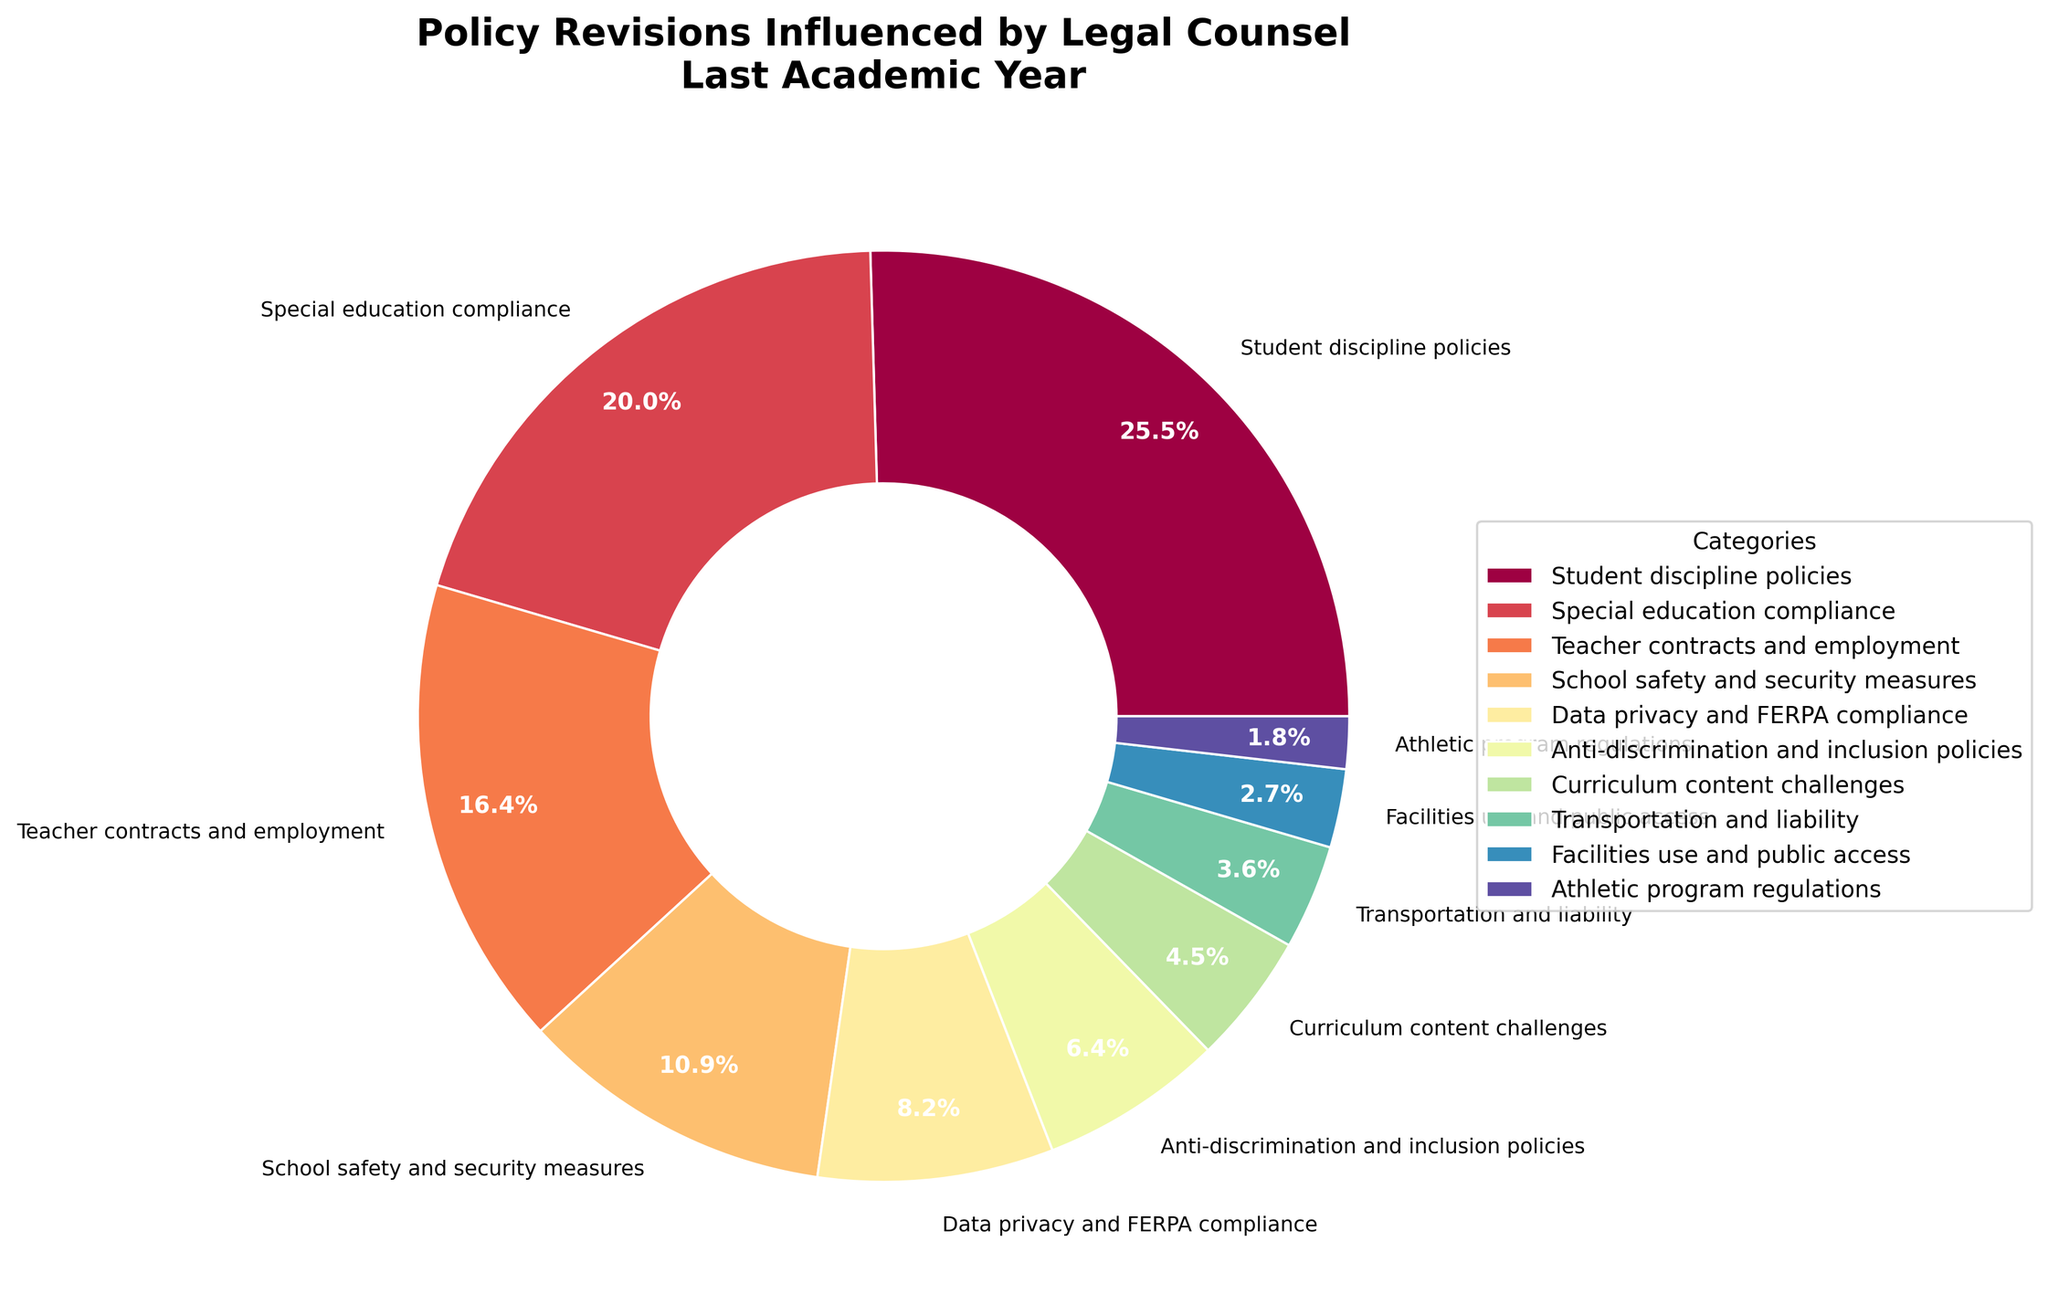Which category accounts for the highest percentage of policy revisions influenced by legal counsel? Student discipline policies account for the highest percentage at 28%. This can be directly observed from the figure where the 'Student discipline policies' segment is the largest.
Answer: Student discipline policies (28%) How much larger is the percentage for 'Student discipline policies' compared to 'School safety and security measures'? To find the difference, subtract the smaller percentage from the larger one. That is 28% (Student discipline policies) - 12% (School safety and security measures) = 16%.
Answer: 16% What's the combined percentage of policy revisions influenced by legal counsel for 'Teacher contracts and employment' and 'Special education compliance'? Sum the percentages for 'Teacher contracts and employment' (18%) and 'Special education compliance' (22%). So, 18% + 22% = 40%.
Answer: 40% Which categories are indicated by shades of red in the pie chart? Without specifying exact color codes, we look at the visual hues on the chart. By observing, the categories 'Student discipline policies' and 'Anti-discrimination and inclusion policies' are represented by shades of red.
Answer: Student discipline policies and Anti-discrimination and inclusion policies Are there any categories influenced equally by legal counsel? No, all categories have unique percentages, indicating that none are equally influenced. This is observed by visually checking that each segment has a different size and percentage label.
Answer: No What percentage of policy revisions are influenced by legal counsel in categories related to student issues (Student discipline policies and Special education compliance)? Sum the percentages of the 'Student discipline policies' (28%) and 'Special education compliance' (22%). So, 28% + 22% = 50%.
Answer: 50% By how much does the influence on 'Teacher contracts and employment' exceed that on 'Facilities use and public access'? Subtract the percentage for 'Facilities use and public access' from 'Teacher contracts and employment': 18% (Teacher contracts and employment) - 3% (Facilities use and public access) = 15%.
Answer: 15% What is the percentage difference between the highest and lowest influenced categories? The highest influenced category is 'Student discipline policies' (28%) and the lowest is 'Athletic program regulations' (2%). Subtract the lowest from the highest: 28% - 2% = 26%.
Answer: 26% What is the percentage for 'Data privacy and FERPA compliance' compared to 'Anti-discrimination and inclusion policies'? 'Data privacy and FERPA compliance' is 9%, whereas 'Anti-discrimination and inclusion policies' is 7%. Visually, 9% is greater than 7%, with a difference of 2%.
Answer: 9% vs 7% If the category with the largest influence had its percentage reduced by 10%, what would be the new percentage? The category with the largest influence is 'Student discipline policies' at 28%. If reduced by 10%, the new percentage would be 28% - 10% = 18%.
Answer: 18% 